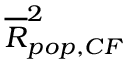Convert formula to latex. <formula><loc_0><loc_0><loc_500><loc_500>\overline { R } _ { p o p , C F } ^ { 2 }</formula> 